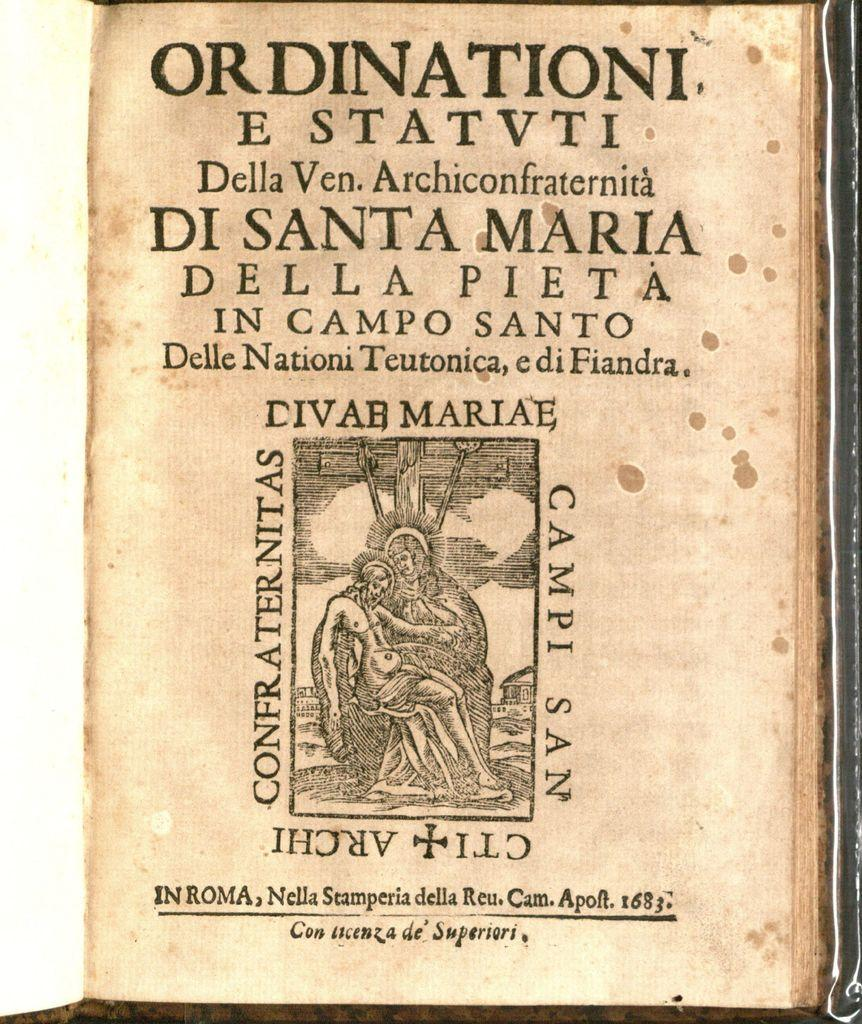<image>
Describe the image concisely. A page of a book that is titiled Ordinationi E Statvti. 